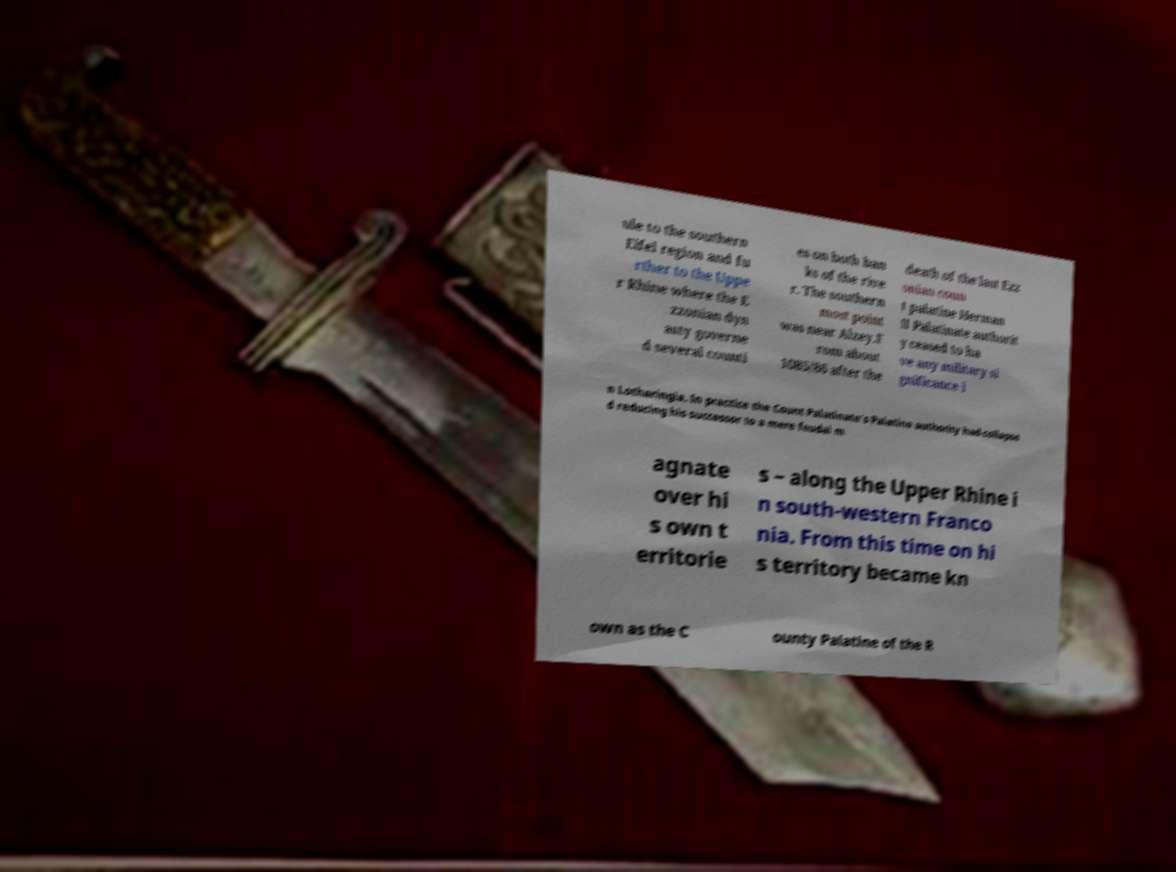What messages or text are displayed in this image? I need them in a readable, typed format. ule to the southern Eifel region and fu rther to the Uppe r Rhine where the E zzonian dyn asty governe d several counti es on both ban ks of the rive r. The southern most point was near Alzey.F rom about 1085/86 after the death of the last Ezz onian coun t palatine Herman II Palatinate authorit y ceased to ha ve any military si gnificance i n Lotharingia. In practice the Count Palatinate's Palatine authority had collapse d reducing his successor to a mere feudal m agnate over hi s own t erritorie s – along the Upper Rhine i n south-western Franco nia. From this time on hi s territory became kn own as the C ounty Palatine of the R 